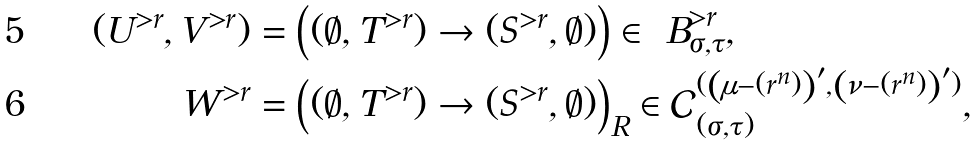Convert formula to latex. <formula><loc_0><loc_0><loc_500><loc_500>( U ^ { > r } , V ^ { > r } ) & = \left ( ( \emptyset , T ^ { > r } ) \rightarrow ( S ^ { > r } , \emptyset ) \right ) \in \ B ^ { > r } _ { \sigma , \tau } , \\ W ^ { > r } & = \left ( ( \emptyset , T ^ { > r } ) \rightarrow ( S ^ { > r } , \emptyset ) \right ) _ { R } \in \mathcal { C } ^ { ( \left ( \mu - ( r ^ { n } ) \right ) ^ { \prime } , \left ( \nu - ( r ^ { n } ) \right ) ^ { \prime } ) } _ { ( \sigma , \tau ) } ,</formula> 